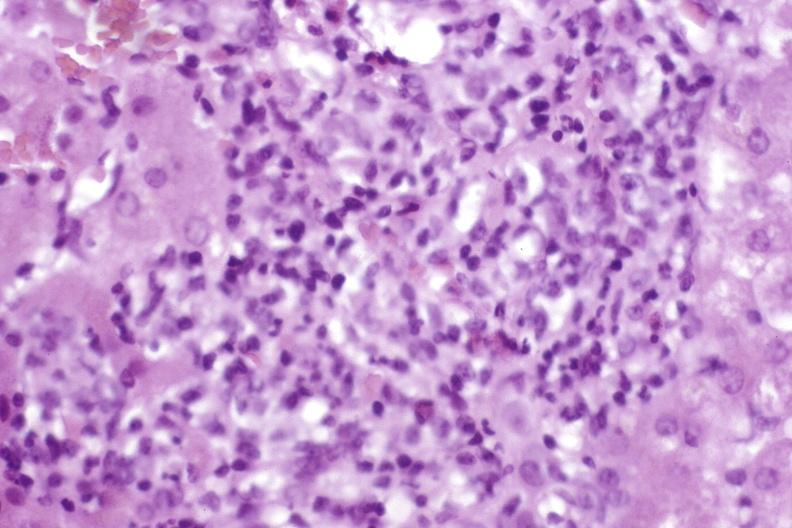does pituitary show moderate acute rejection?
Answer the question using a single word or phrase. No 